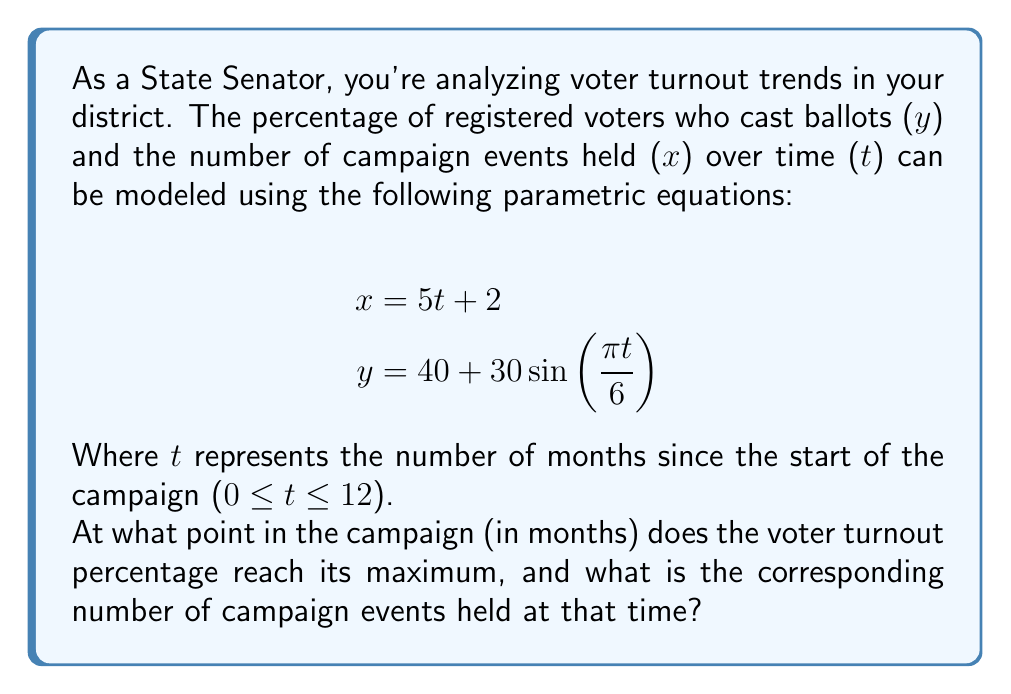Provide a solution to this math problem. To solve this problem, we need to follow these steps:

1) First, we need to find when the voter turnout percentage (y) reaches its maximum. Since y is a sine function, it will reach its maximum when the argument of sine is π/2 (or 90 degrees).

2) Let's set up the equation:

   $$\frac{\pi t}{6} = \frac{\pi}{2}$$

3) Solve for t:
   
   $$t = \frac{6}{2} = 3$$

4) This means the voter turnout percentage reaches its maximum 3 months into the campaign.

5) To find the number of campaign events at this time, we substitute t = 3 into the equation for x:

   $$x = 5(3) + 2 = 15 + 2 = 17$$

6) We can verify the maximum voter turnout percentage by substituting t = 3 into the equation for y:

   $$y = 40 + 30\sin(\frac{\pi(3)}{6}) = 40 + 30\sin(\frac{\pi}{2}) = 40 + 30 = 70$$

   This is indeed the maximum, as sine reaches its maximum value of 1 at π/2.
Answer: The voter turnout percentage reaches its maximum 3 months into the campaign, at which point 17 campaign events have been held. 